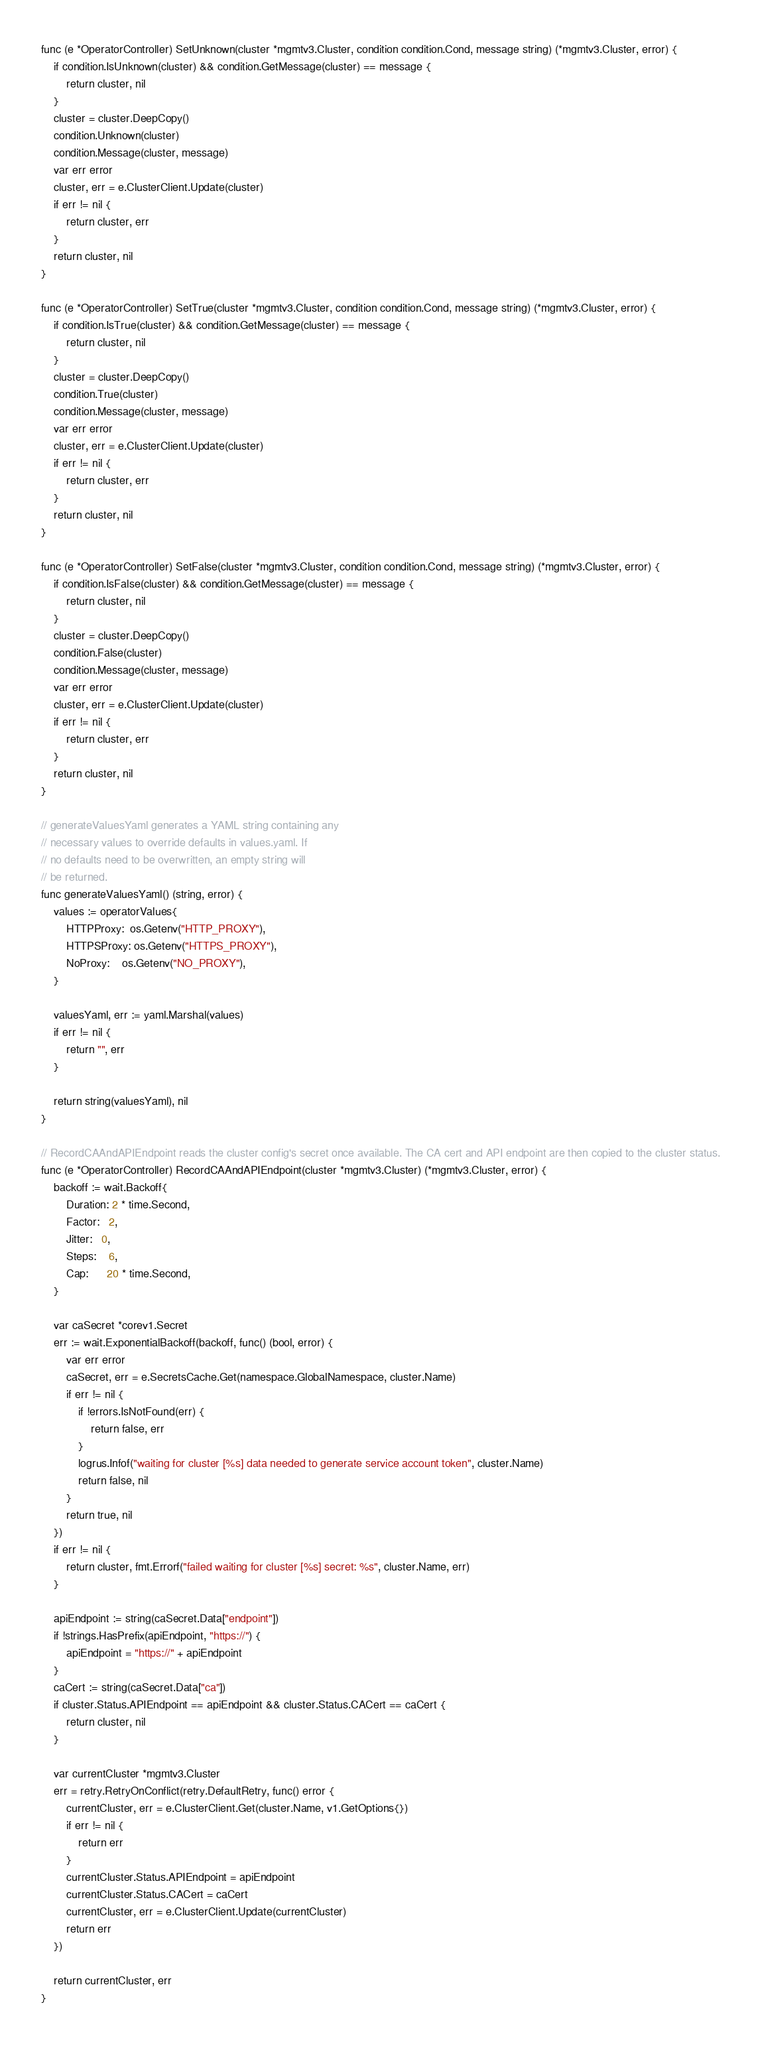<code> <loc_0><loc_0><loc_500><loc_500><_Go_>
func (e *OperatorController) SetUnknown(cluster *mgmtv3.Cluster, condition condition.Cond, message string) (*mgmtv3.Cluster, error) {
	if condition.IsUnknown(cluster) && condition.GetMessage(cluster) == message {
		return cluster, nil
	}
	cluster = cluster.DeepCopy()
	condition.Unknown(cluster)
	condition.Message(cluster, message)
	var err error
	cluster, err = e.ClusterClient.Update(cluster)
	if err != nil {
		return cluster, err
	}
	return cluster, nil
}

func (e *OperatorController) SetTrue(cluster *mgmtv3.Cluster, condition condition.Cond, message string) (*mgmtv3.Cluster, error) {
	if condition.IsTrue(cluster) && condition.GetMessage(cluster) == message {
		return cluster, nil
	}
	cluster = cluster.DeepCopy()
	condition.True(cluster)
	condition.Message(cluster, message)
	var err error
	cluster, err = e.ClusterClient.Update(cluster)
	if err != nil {
		return cluster, err
	}
	return cluster, nil
}

func (e *OperatorController) SetFalse(cluster *mgmtv3.Cluster, condition condition.Cond, message string) (*mgmtv3.Cluster, error) {
	if condition.IsFalse(cluster) && condition.GetMessage(cluster) == message {
		return cluster, nil
	}
	cluster = cluster.DeepCopy()
	condition.False(cluster)
	condition.Message(cluster, message)
	var err error
	cluster, err = e.ClusterClient.Update(cluster)
	if err != nil {
		return cluster, err
	}
	return cluster, nil
}

// generateValuesYaml generates a YAML string containing any
// necessary values to override defaults in values.yaml. If
// no defaults need to be overwritten, an empty string will
// be returned.
func generateValuesYaml() (string, error) {
	values := operatorValues{
		HTTPProxy:  os.Getenv("HTTP_PROXY"),
		HTTPSProxy: os.Getenv("HTTPS_PROXY"),
		NoProxy:    os.Getenv("NO_PROXY"),
	}

	valuesYaml, err := yaml.Marshal(values)
	if err != nil {
		return "", err
	}

	return string(valuesYaml), nil
}

// RecordCAAndAPIEndpoint reads the cluster config's secret once available. The CA cert and API endpoint are then copied to the cluster status.
func (e *OperatorController) RecordCAAndAPIEndpoint(cluster *mgmtv3.Cluster) (*mgmtv3.Cluster, error) {
	backoff := wait.Backoff{
		Duration: 2 * time.Second,
		Factor:   2,
		Jitter:   0,
		Steps:    6,
		Cap:      20 * time.Second,
	}

	var caSecret *corev1.Secret
	err := wait.ExponentialBackoff(backoff, func() (bool, error) {
		var err error
		caSecret, err = e.SecretsCache.Get(namespace.GlobalNamespace, cluster.Name)
		if err != nil {
			if !errors.IsNotFound(err) {
				return false, err
			}
			logrus.Infof("waiting for cluster [%s] data needed to generate service account token", cluster.Name)
			return false, nil
		}
		return true, nil
	})
	if err != nil {
		return cluster, fmt.Errorf("failed waiting for cluster [%s] secret: %s", cluster.Name, err)
	}

	apiEndpoint := string(caSecret.Data["endpoint"])
	if !strings.HasPrefix(apiEndpoint, "https://") {
		apiEndpoint = "https://" + apiEndpoint
	}
	caCert := string(caSecret.Data["ca"])
	if cluster.Status.APIEndpoint == apiEndpoint && cluster.Status.CACert == caCert {
		return cluster, nil
	}

	var currentCluster *mgmtv3.Cluster
	err = retry.RetryOnConflict(retry.DefaultRetry, func() error {
		currentCluster, err = e.ClusterClient.Get(cluster.Name, v1.GetOptions{})
		if err != nil {
			return err
		}
		currentCluster.Status.APIEndpoint = apiEndpoint
		currentCluster.Status.CACert = caCert
		currentCluster, err = e.ClusterClient.Update(currentCluster)
		return err
	})

	return currentCluster, err
}
</code> 